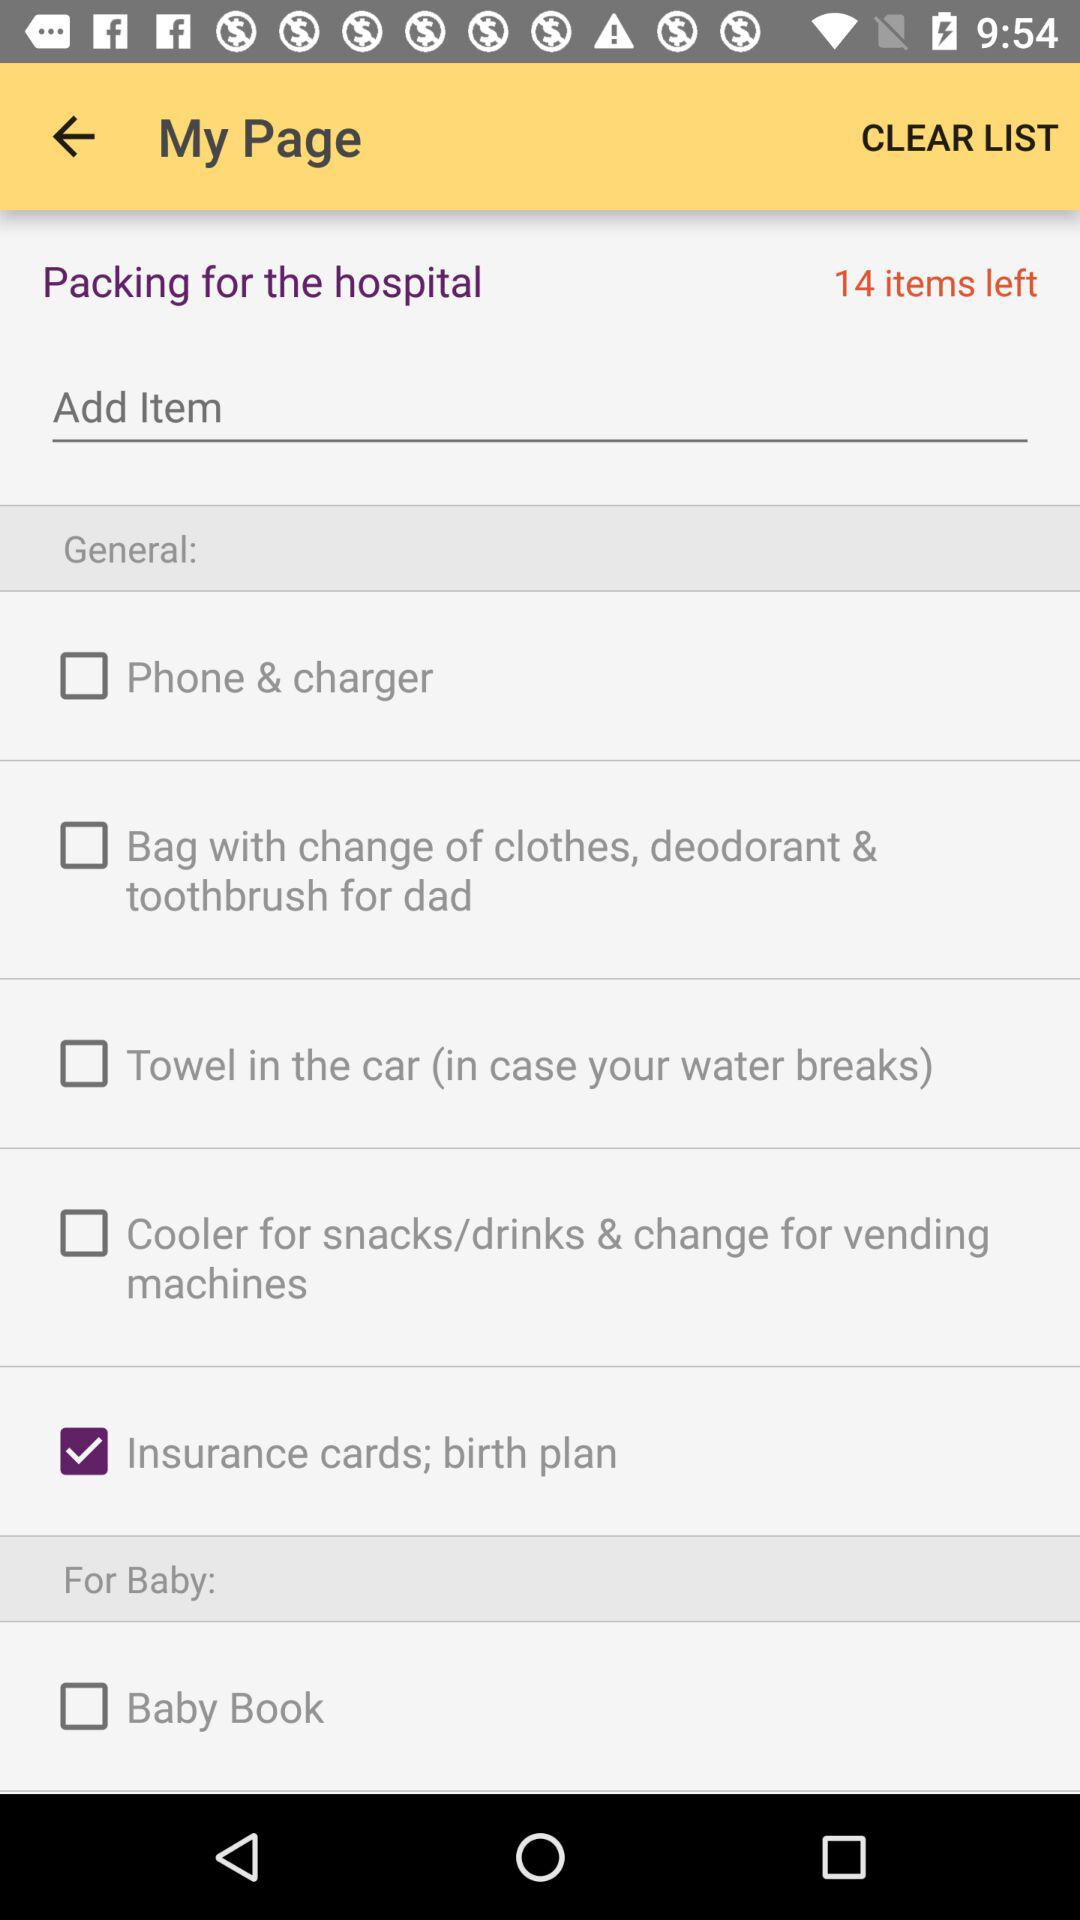How many items are left? There are 14 items left. 